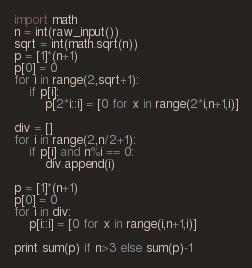Convert code to text. <code><loc_0><loc_0><loc_500><loc_500><_Python_>import math
n = int(raw_input())
sqrt = int(math.sqrt(n))
p = [1]*(n+1)
p[0] = 0
for i in range(2,sqrt+1):
	if p[i]:
		p[2*i::i] = [0 for x in range(2*i,n+1,i)]

div = []
for i in range(2,n/2+1):
	if p[i] and n%i == 0:
		div.append(i)

p = [1]*(n+1)
p[0] = 0
for i in div:
	p[i::i] = [0 for x in range(i,n+1,i)]
	
print sum(p) if n>3 else sum(p)-1 </code> 